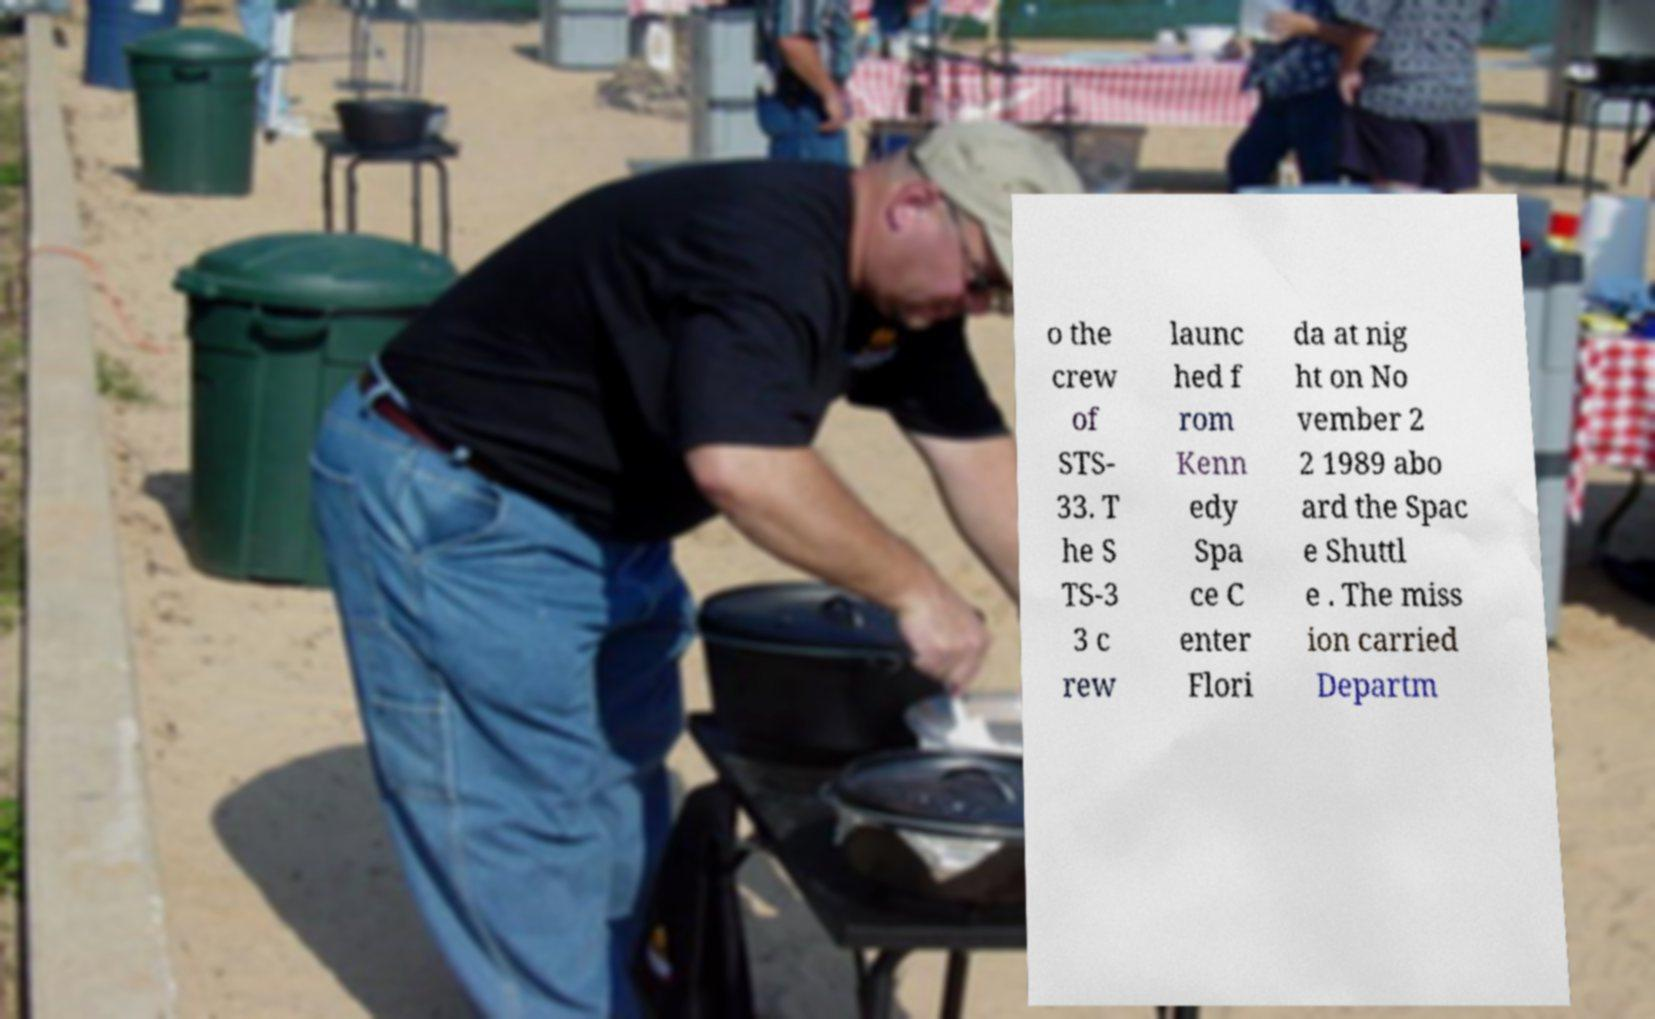There's text embedded in this image that I need extracted. Can you transcribe it verbatim? o the crew of STS- 33. T he S TS-3 3 c rew launc hed f rom Kenn edy Spa ce C enter Flori da at nig ht on No vember 2 2 1989 abo ard the Spac e Shuttl e . The miss ion carried Departm 